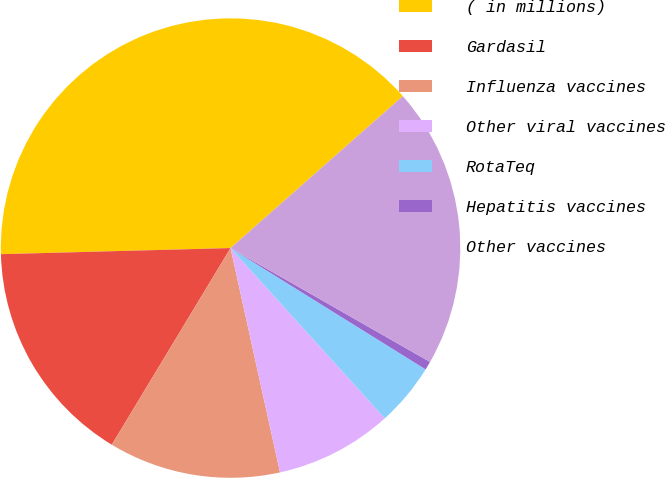<chart> <loc_0><loc_0><loc_500><loc_500><pie_chart><fcel>( in millions)<fcel>Gardasil<fcel>Influenza vaccines<fcel>Other viral vaccines<fcel>RotaTeq<fcel>Hepatitis vaccines<fcel>Other vaccines<nl><fcel>38.92%<fcel>15.93%<fcel>12.1%<fcel>8.26%<fcel>4.43%<fcel>0.6%<fcel>19.76%<nl></chart> 